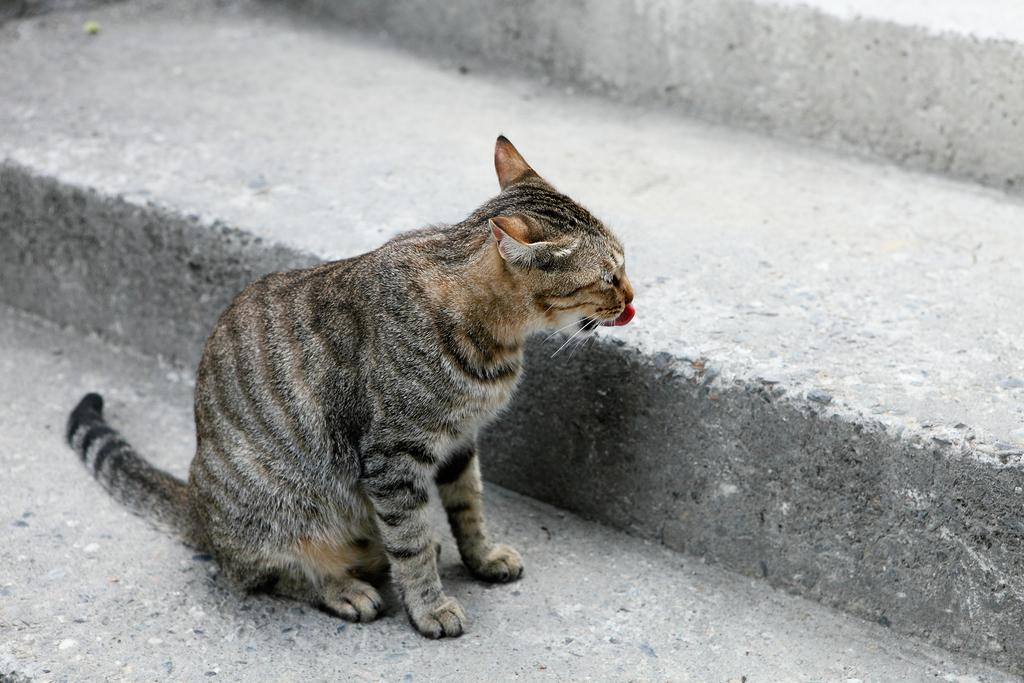What type of animal is in the image? There is a cat in the image. What colors can be seen on the cat? The cat has brown, black, and white colors. Where is the cat located in the image? The cat is on the stairs. What type of lamp is the actor holding in the image? There is no actor or lamp present in the image; it features a cat on the stairs. 